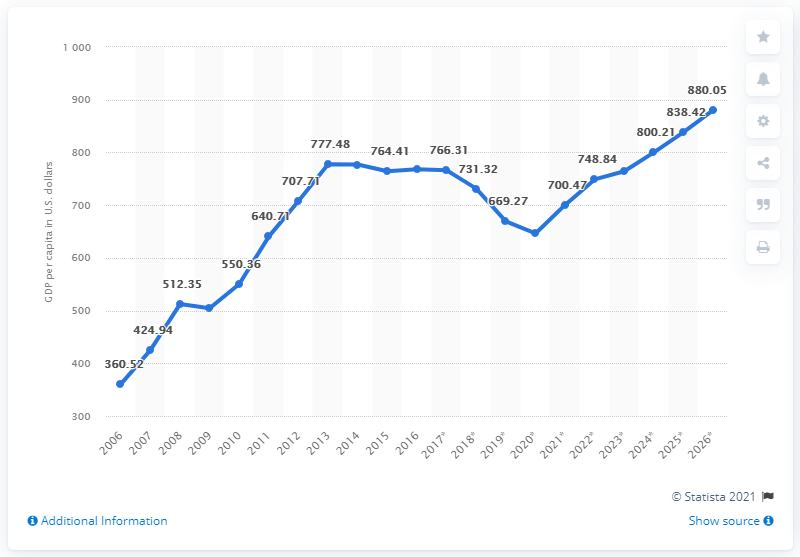Mention a couple of crucial points in this snapshot. The GDP per capita in Liberia in 2018 was 731.32. 